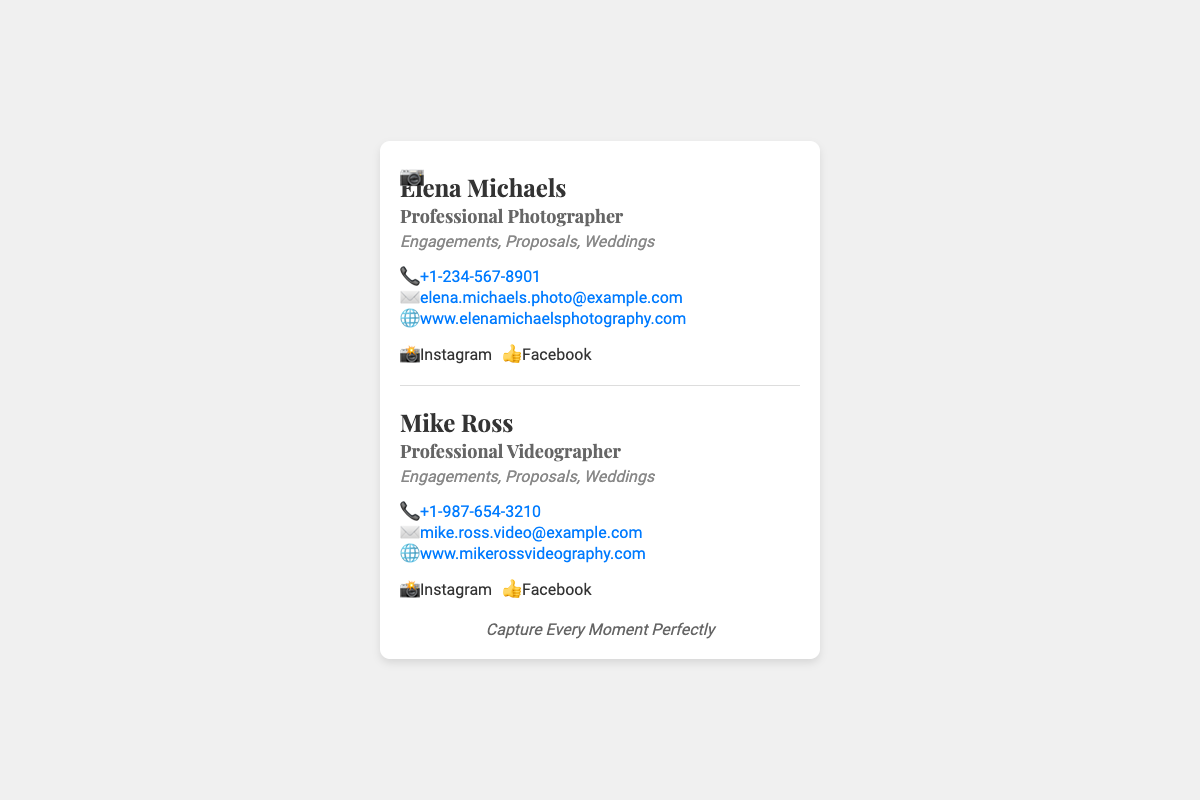What is the name of the photographer? The name of the photographer is mentioned prominently at the top of the photographer's section.
Answer: Elena Michaels What is the photographer's email address? The email address is listed in the contact information section of the photographer.
Answer: elena.michaels.photo@example.com What services does Mike Ross specialize in? The specialties of Mike Ross are displayed below his title, indicating what he focuses on.
Answer: Engagements, Proposals, Weddings What is the phone number for the videographer? The phone number is provided in the contact information section for the videographer.
Answer: +1-987-654-3210 How many social media links are listed for each professional? By reviewing the social media section for both the photographer and videographer, we count the links.
Answer: 2 What visual element represents the photography theme? A specific icon is included in the design to symbolize the photography focus.
Answer: Camera icon Which professional has a website listed? Both professionals have websites, but this question asks about one of them specifically.
Answer: Both What is the color theme of the card? The card uses a white background with text colors that are neatly specified in the styles.
Answer: White and gray tones What is the main message at the bottom of the card? The note at the bottom conveys an important theme of the service being offered.
Answer: Capture Every Moment Perfectly 